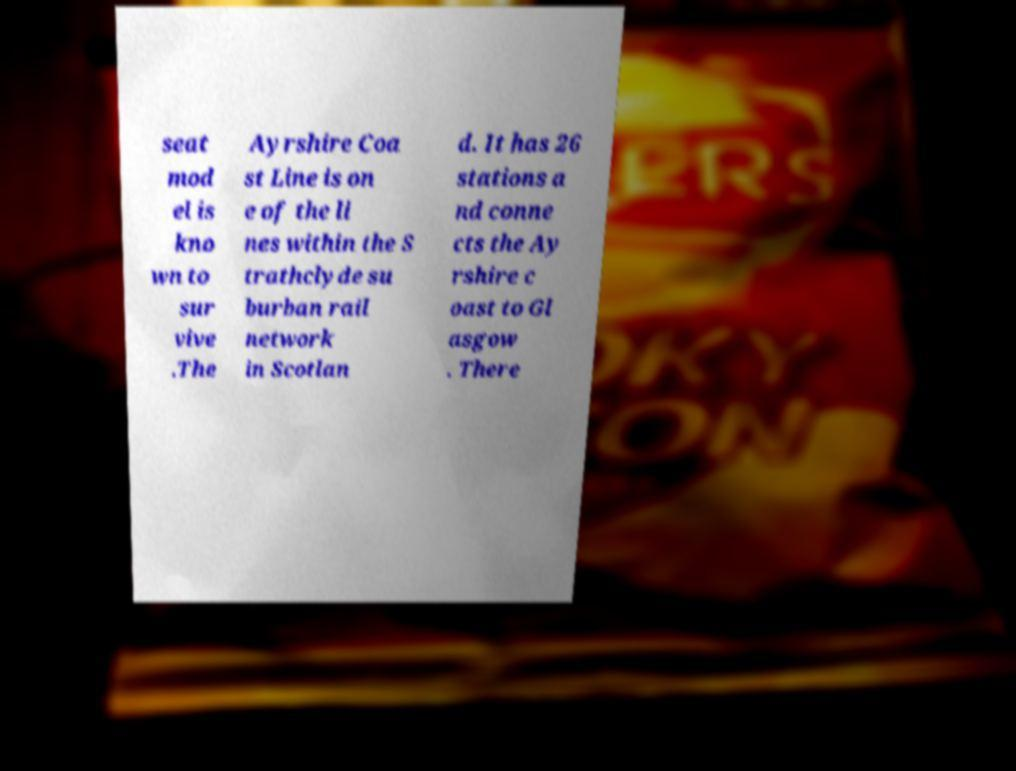There's text embedded in this image that I need extracted. Can you transcribe it verbatim? seat mod el is kno wn to sur vive .The Ayrshire Coa st Line is on e of the li nes within the S trathclyde su burban rail network in Scotlan d. It has 26 stations a nd conne cts the Ay rshire c oast to Gl asgow . There 